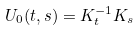<formula> <loc_0><loc_0><loc_500><loc_500>U _ { 0 } ( t , s ) = K _ { t } ^ { - 1 } K _ { s }</formula> 